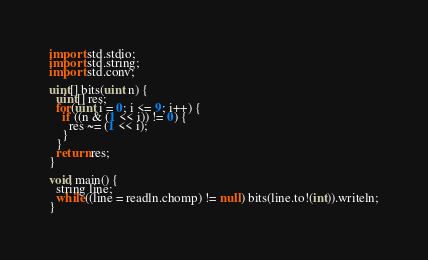<code> <loc_0><loc_0><loc_500><loc_500><_D_>
import std.stdio;
import std.string;
import std.conv;

uint[] bits(uint n) {
  uint[] res;
  for(uint i = 0; i <= 9; i++) {
    if ((n & (1 << i)) != 0) {
      res ~= (1 << i);
    }
  }
  return res;
}

void main() {
  string line;
  while((line = readln.chomp) != null) bits(line.to!(int)).writeln;
}</code> 